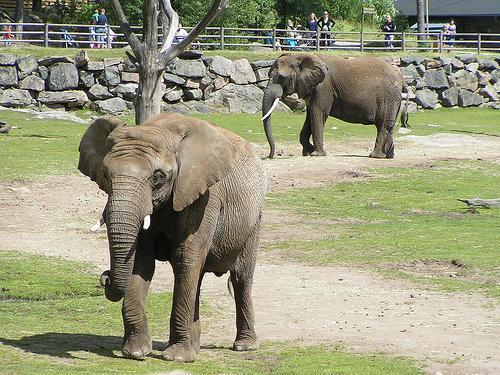How many elephants are there?
Give a very brief answer. 2. 